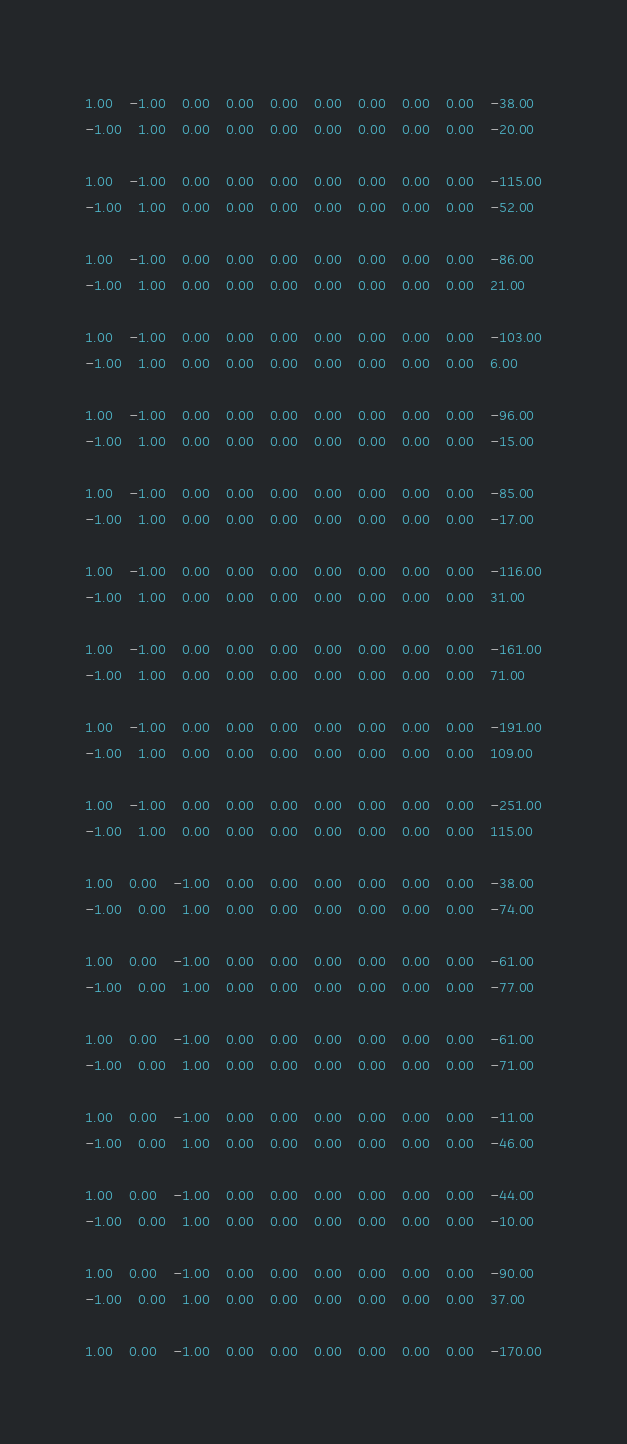Convert code to text. <code><loc_0><loc_0><loc_500><loc_500><_Matlab_>1.00	-1.00	0.00	0.00	0.00	0.00	0.00	0.00	0.00	-38.00
-1.00	1.00	0.00	0.00	0.00	0.00	0.00	0.00	0.00	-20.00

1.00	-1.00	0.00	0.00	0.00	0.00	0.00	0.00	0.00	-115.00
-1.00	1.00	0.00	0.00	0.00	0.00	0.00	0.00	0.00	-52.00

1.00	-1.00	0.00	0.00	0.00	0.00	0.00	0.00	0.00	-86.00
-1.00	1.00	0.00	0.00	0.00	0.00	0.00	0.00	0.00	21.00

1.00	-1.00	0.00	0.00	0.00	0.00	0.00	0.00	0.00	-103.00
-1.00	1.00	0.00	0.00	0.00	0.00	0.00	0.00	0.00	6.00

1.00	-1.00	0.00	0.00	0.00	0.00	0.00	0.00	0.00	-96.00
-1.00	1.00	0.00	0.00	0.00	0.00	0.00	0.00	0.00	-15.00

1.00	-1.00	0.00	0.00	0.00	0.00	0.00	0.00	0.00	-85.00
-1.00	1.00	0.00	0.00	0.00	0.00	0.00	0.00	0.00	-17.00

1.00	-1.00	0.00	0.00	0.00	0.00	0.00	0.00	0.00	-116.00
-1.00	1.00	0.00	0.00	0.00	0.00	0.00	0.00	0.00	31.00

1.00	-1.00	0.00	0.00	0.00	0.00	0.00	0.00	0.00	-161.00
-1.00	1.00	0.00	0.00	0.00	0.00	0.00	0.00	0.00	71.00

1.00	-1.00	0.00	0.00	0.00	0.00	0.00	0.00	0.00	-191.00
-1.00	1.00	0.00	0.00	0.00	0.00	0.00	0.00	0.00	109.00

1.00	-1.00	0.00	0.00	0.00	0.00	0.00	0.00	0.00	-251.00
-1.00	1.00	0.00	0.00	0.00	0.00	0.00	0.00	0.00	115.00

1.00	0.00	-1.00	0.00	0.00	0.00	0.00	0.00	0.00	-38.00
-1.00	0.00	1.00	0.00	0.00	0.00	0.00	0.00	0.00	-74.00

1.00	0.00	-1.00	0.00	0.00	0.00	0.00	0.00	0.00	-61.00
-1.00	0.00	1.00	0.00	0.00	0.00	0.00	0.00	0.00	-77.00

1.00	0.00	-1.00	0.00	0.00	0.00	0.00	0.00	0.00	-61.00
-1.00	0.00	1.00	0.00	0.00	0.00	0.00	0.00	0.00	-71.00

1.00	0.00	-1.00	0.00	0.00	0.00	0.00	0.00	0.00	-11.00
-1.00	0.00	1.00	0.00	0.00	0.00	0.00	0.00	0.00	-46.00

1.00	0.00	-1.00	0.00	0.00	0.00	0.00	0.00	0.00	-44.00
-1.00	0.00	1.00	0.00	0.00	0.00	0.00	0.00	0.00	-10.00

1.00	0.00	-1.00	0.00	0.00	0.00	0.00	0.00	0.00	-90.00
-1.00	0.00	1.00	0.00	0.00	0.00	0.00	0.00	0.00	37.00

1.00	0.00	-1.00	0.00	0.00	0.00	0.00	0.00	0.00	-170.00</code> 